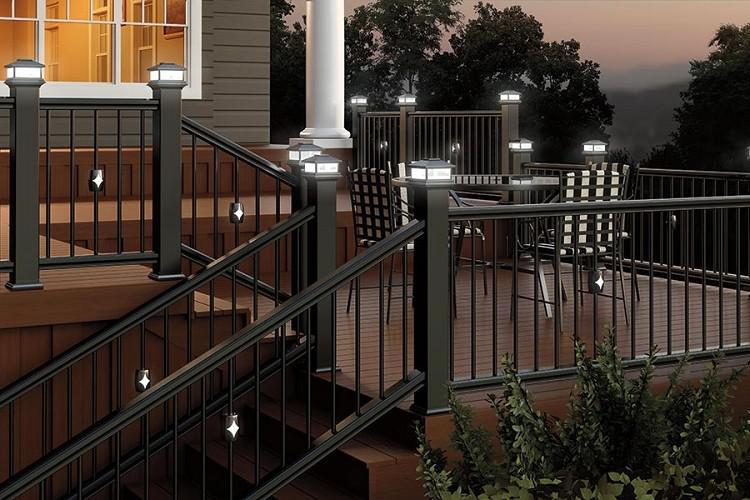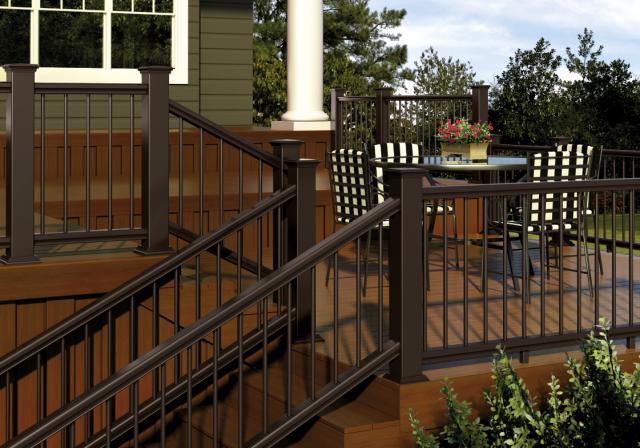The first image is the image on the left, the second image is the image on the right. Evaluate the accuracy of this statement regarding the images: "An image includes ascending stairs with dark brown rails and dark bars, and square corner posts with no lights on top.". Is it true? Answer yes or no. Yes. 